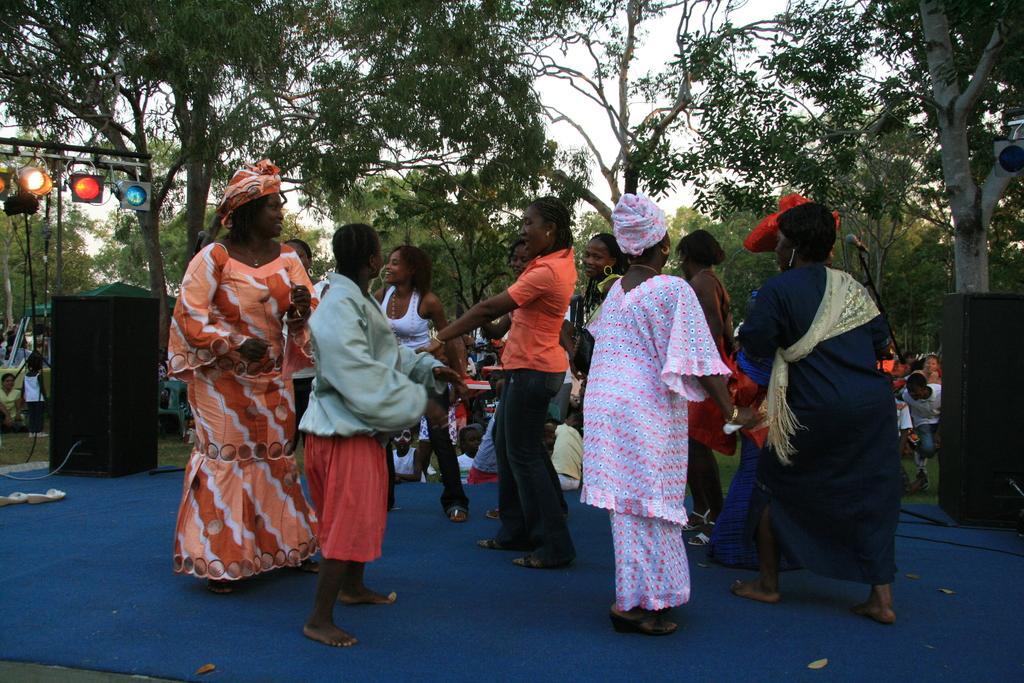Could you give a brief overview of what you see in this image? In the center of the image we can see people standing. They are wearing costumes. On the left there are lights and we can see a speaker. In the background there are trees, people and sky. At the bottom there is a carpet. 